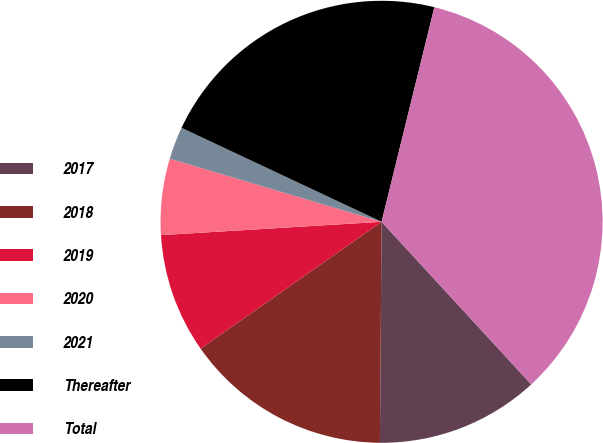Convert chart. <chart><loc_0><loc_0><loc_500><loc_500><pie_chart><fcel>2017<fcel>2018<fcel>2019<fcel>2020<fcel>2021<fcel>Thereafter<fcel>Total<nl><fcel>11.96%<fcel>15.15%<fcel>8.77%<fcel>5.57%<fcel>2.38%<fcel>21.85%<fcel>34.32%<nl></chart> 